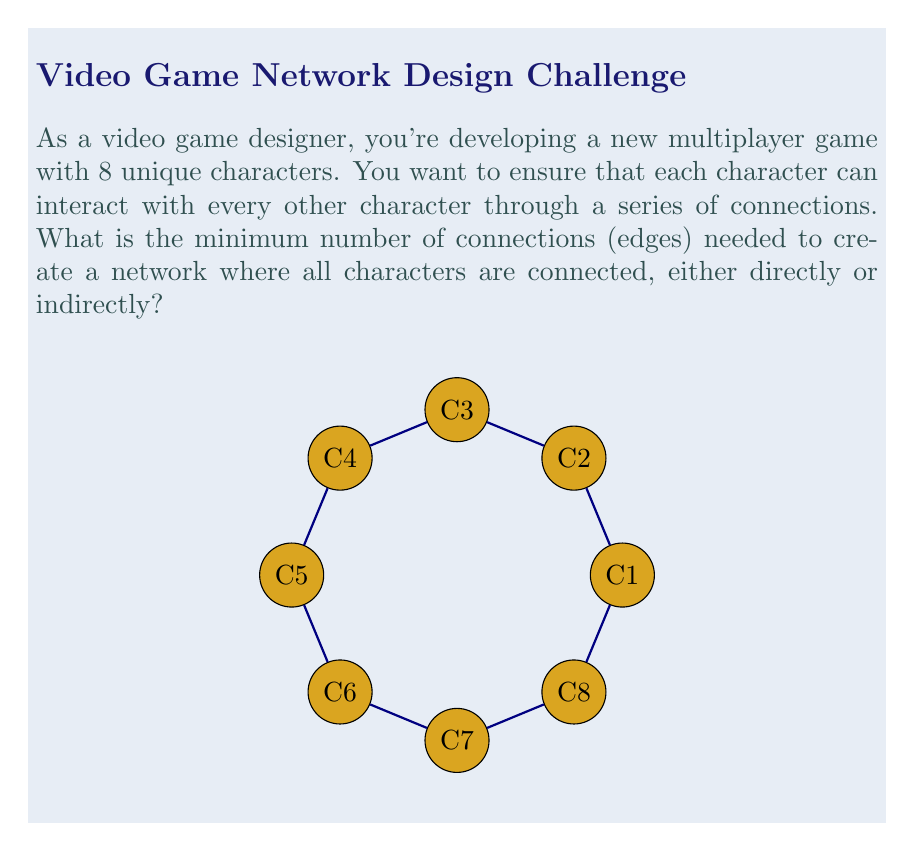Solve this math problem. To solve this problem, we can use the concept of a minimum spanning tree from graph theory. In a game network where all characters need to be connected:

1. Each character represents a vertex in the graph.
2. The connections between characters represent edges.
3. The minimum number of edges needed to connect all vertices in a graph is given by the formula for a minimum spanning tree:

   $$E_{min} = V - 1$$

   Where $E_{min}$ is the minimum number of edges, and $V$ is the number of vertices.

4. In this case, we have 8 characters, so $V = 8$.

5. Applying the formula:

   $$E_{min} = 8 - 1 = 7$$

This solution ensures that all characters are connected with the minimum number of edges, forming a tree-like structure without any cycles. Each additional character would require one more edge to connect it to the existing network.
Answer: $7$ edges 